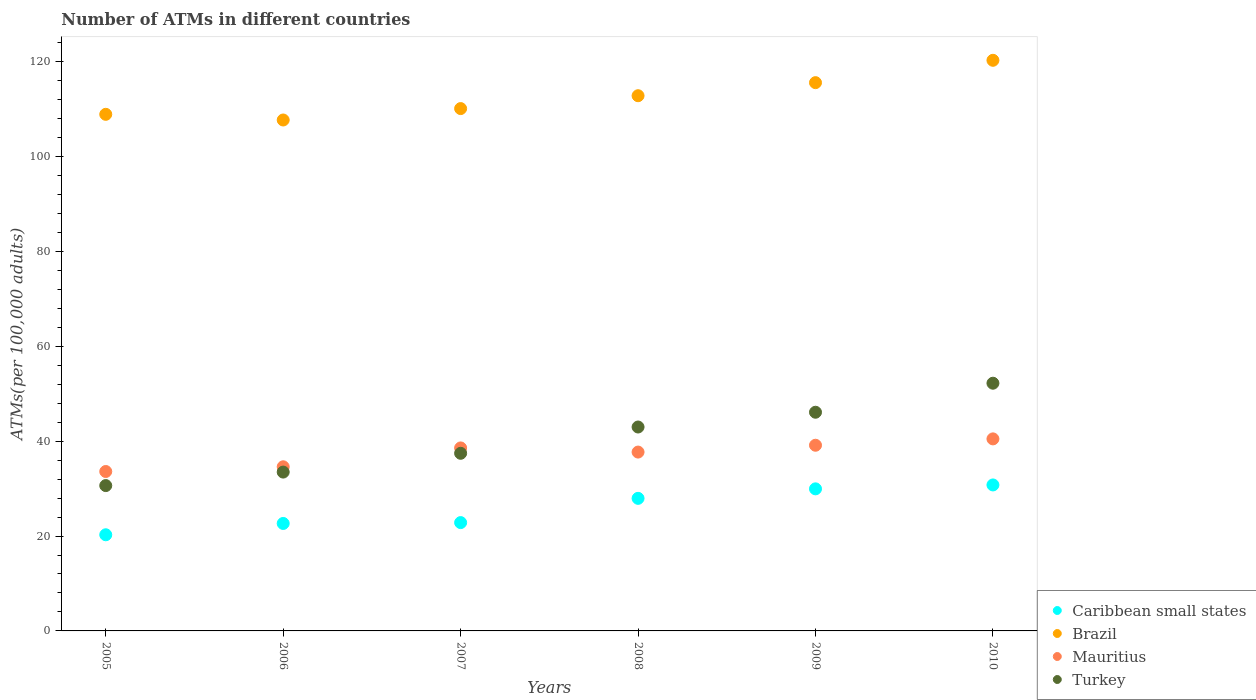What is the number of ATMs in Brazil in 2005?
Your answer should be compact. 108.88. Across all years, what is the maximum number of ATMs in Mauritius?
Your answer should be compact. 40.47. Across all years, what is the minimum number of ATMs in Turkey?
Your answer should be very brief. 30.63. In which year was the number of ATMs in Turkey maximum?
Offer a terse response. 2010. In which year was the number of ATMs in Mauritius minimum?
Provide a short and direct response. 2005. What is the total number of ATMs in Mauritius in the graph?
Provide a short and direct response. 224.06. What is the difference between the number of ATMs in Brazil in 2005 and that in 2010?
Provide a short and direct response. -11.39. What is the difference between the number of ATMs in Brazil in 2008 and the number of ATMs in Caribbean small states in 2007?
Offer a terse response. 89.97. What is the average number of ATMs in Turkey per year?
Provide a succinct answer. 40.47. In the year 2007, what is the difference between the number of ATMs in Caribbean small states and number of ATMs in Brazil?
Your answer should be very brief. -87.26. What is the ratio of the number of ATMs in Turkey in 2006 to that in 2010?
Offer a very short reply. 0.64. Is the number of ATMs in Turkey in 2006 less than that in 2007?
Provide a short and direct response. Yes. Is the difference between the number of ATMs in Caribbean small states in 2006 and 2009 greater than the difference between the number of ATMs in Brazil in 2006 and 2009?
Provide a succinct answer. Yes. What is the difference between the highest and the second highest number of ATMs in Mauritius?
Provide a succinct answer. 1.34. What is the difference between the highest and the lowest number of ATMs in Caribbean small states?
Offer a very short reply. 10.5. In how many years, is the number of ATMs in Turkey greater than the average number of ATMs in Turkey taken over all years?
Your response must be concise. 3. Is the sum of the number of ATMs in Turkey in 2008 and 2010 greater than the maximum number of ATMs in Mauritius across all years?
Keep it short and to the point. Yes. Does the number of ATMs in Turkey monotonically increase over the years?
Provide a succinct answer. Yes. Is the number of ATMs in Brazil strictly greater than the number of ATMs in Mauritius over the years?
Your response must be concise. Yes. Is the number of ATMs in Mauritius strictly less than the number of ATMs in Turkey over the years?
Provide a succinct answer. No. How many years are there in the graph?
Your answer should be very brief. 6. What is the difference between two consecutive major ticks on the Y-axis?
Offer a terse response. 20. Does the graph contain any zero values?
Offer a terse response. No. Does the graph contain grids?
Give a very brief answer. No. What is the title of the graph?
Give a very brief answer. Number of ATMs in different countries. What is the label or title of the X-axis?
Ensure brevity in your answer.  Years. What is the label or title of the Y-axis?
Provide a short and direct response. ATMs(per 100,0 adults). What is the ATMs(per 100,000 adults) of Caribbean small states in 2005?
Provide a short and direct response. 20.26. What is the ATMs(per 100,000 adults) of Brazil in 2005?
Keep it short and to the point. 108.88. What is the ATMs(per 100,000 adults) of Mauritius in 2005?
Offer a very short reply. 33.6. What is the ATMs(per 100,000 adults) in Turkey in 2005?
Your response must be concise. 30.63. What is the ATMs(per 100,000 adults) in Caribbean small states in 2006?
Your response must be concise. 22.65. What is the ATMs(per 100,000 adults) of Brazil in 2006?
Keep it short and to the point. 107.68. What is the ATMs(per 100,000 adults) of Mauritius in 2006?
Your response must be concise. 34.59. What is the ATMs(per 100,000 adults) of Turkey in 2006?
Offer a very short reply. 33.48. What is the ATMs(per 100,000 adults) of Caribbean small states in 2007?
Offer a terse response. 22.83. What is the ATMs(per 100,000 adults) of Brazil in 2007?
Provide a short and direct response. 110.09. What is the ATMs(per 100,000 adults) of Mauritius in 2007?
Give a very brief answer. 38.57. What is the ATMs(per 100,000 adults) of Turkey in 2007?
Your answer should be very brief. 37.44. What is the ATMs(per 100,000 adults) of Caribbean small states in 2008?
Your response must be concise. 27.94. What is the ATMs(per 100,000 adults) in Brazil in 2008?
Provide a short and direct response. 112.8. What is the ATMs(per 100,000 adults) of Mauritius in 2008?
Your response must be concise. 37.69. What is the ATMs(per 100,000 adults) in Turkey in 2008?
Offer a terse response. 42.98. What is the ATMs(per 100,000 adults) of Caribbean small states in 2009?
Provide a succinct answer. 29.94. What is the ATMs(per 100,000 adults) in Brazil in 2009?
Offer a terse response. 115.55. What is the ATMs(per 100,000 adults) in Mauritius in 2009?
Ensure brevity in your answer.  39.13. What is the ATMs(per 100,000 adults) of Turkey in 2009?
Keep it short and to the point. 46.09. What is the ATMs(per 100,000 adults) of Caribbean small states in 2010?
Offer a very short reply. 30.77. What is the ATMs(per 100,000 adults) of Brazil in 2010?
Your response must be concise. 120.26. What is the ATMs(per 100,000 adults) in Mauritius in 2010?
Your response must be concise. 40.47. What is the ATMs(per 100,000 adults) of Turkey in 2010?
Your answer should be compact. 52.21. Across all years, what is the maximum ATMs(per 100,000 adults) of Caribbean small states?
Give a very brief answer. 30.77. Across all years, what is the maximum ATMs(per 100,000 adults) of Brazil?
Provide a succinct answer. 120.26. Across all years, what is the maximum ATMs(per 100,000 adults) of Mauritius?
Offer a very short reply. 40.47. Across all years, what is the maximum ATMs(per 100,000 adults) of Turkey?
Your response must be concise. 52.21. Across all years, what is the minimum ATMs(per 100,000 adults) of Caribbean small states?
Make the answer very short. 20.26. Across all years, what is the minimum ATMs(per 100,000 adults) of Brazil?
Your answer should be compact. 107.68. Across all years, what is the minimum ATMs(per 100,000 adults) of Mauritius?
Your response must be concise. 33.6. Across all years, what is the minimum ATMs(per 100,000 adults) in Turkey?
Your answer should be very brief. 30.63. What is the total ATMs(per 100,000 adults) of Caribbean small states in the graph?
Ensure brevity in your answer.  154.39. What is the total ATMs(per 100,000 adults) of Brazil in the graph?
Provide a succinct answer. 675.26. What is the total ATMs(per 100,000 adults) of Mauritius in the graph?
Keep it short and to the point. 224.06. What is the total ATMs(per 100,000 adults) of Turkey in the graph?
Make the answer very short. 242.81. What is the difference between the ATMs(per 100,000 adults) in Caribbean small states in 2005 and that in 2006?
Provide a succinct answer. -2.38. What is the difference between the ATMs(per 100,000 adults) of Brazil in 2005 and that in 2006?
Your answer should be compact. 1.2. What is the difference between the ATMs(per 100,000 adults) in Mauritius in 2005 and that in 2006?
Offer a very short reply. -0.99. What is the difference between the ATMs(per 100,000 adults) in Turkey in 2005 and that in 2006?
Your answer should be compact. -2.85. What is the difference between the ATMs(per 100,000 adults) in Caribbean small states in 2005 and that in 2007?
Provide a succinct answer. -2.56. What is the difference between the ATMs(per 100,000 adults) of Brazil in 2005 and that in 2007?
Offer a terse response. -1.21. What is the difference between the ATMs(per 100,000 adults) in Mauritius in 2005 and that in 2007?
Your response must be concise. -4.97. What is the difference between the ATMs(per 100,000 adults) in Turkey in 2005 and that in 2007?
Provide a succinct answer. -6.81. What is the difference between the ATMs(per 100,000 adults) in Caribbean small states in 2005 and that in 2008?
Ensure brevity in your answer.  -7.68. What is the difference between the ATMs(per 100,000 adults) of Brazil in 2005 and that in 2008?
Make the answer very short. -3.92. What is the difference between the ATMs(per 100,000 adults) of Mauritius in 2005 and that in 2008?
Make the answer very short. -4.1. What is the difference between the ATMs(per 100,000 adults) of Turkey in 2005 and that in 2008?
Offer a terse response. -12.35. What is the difference between the ATMs(per 100,000 adults) in Caribbean small states in 2005 and that in 2009?
Make the answer very short. -9.68. What is the difference between the ATMs(per 100,000 adults) of Brazil in 2005 and that in 2009?
Give a very brief answer. -6.67. What is the difference between the ATMs(per 100,000 adults) in Mauritius in 2005 and that in 2009?
Keep it short and to the point. -5.53. What is the difference between the ATMs(per 100,000 adults) of Turkey in 2005 and that in 2009?
Offer a terse response. -15.46. What is the difference between the ATMs(per 100,000 adults) in Caribbean small states in 2005 and that in 2010?
Your answer should be very brief. -10.5. What is the difference between the ATMs(per 100,000 adults) of Brazil in 2005 and that in 2010?
Your answer should be very brief. -11.39. What is the difference between the ATMs(per 100,000 adults) of Mauritius in 2005 and that in 2010?
Provide a succinct answer. -6.88. What is the difference between the ATMs(per 100,000 adults) in Turkey in 2005 and that in 2010?
Ensure brevity in your answer.  -21.58. What is the difference between the ATMs(per 100,000 adults) in Caribbean small states in 2006 and that in 2007?
Provide a short and direct response. -0.18. What is the difference between the ATMs(per 100,000 adults) of Brazil in 2006 and that in 2007?
Your response must be concise. -2.4. What is the difference between the ATMs(per 100,000 adults) in Mauritius in 2006 and that in 2007?
Your answer should be compact. -3.97. What is the difference between the ATMs(per 100,000 adults) in Turkey in 2006 and that in 2007?
Make the answer very short. -3.96. What is the difference between the ATMs(per 100,000 adults) in Caribbean small states in 2006 and that in 2008?
Your answer should be compact. -5.29. What is the difference between the ATMs(per 100,000 adults) of Brazil in 2006 and that in 2008?
Give a very brief answer. -5.12. What is the difference between the ATMs(per 100,000 adults) of Mauritius in 2006 and that in 2008?
Ensure brevity in your answer.  -3.1. What is the difference between the ATMs(per 100,000 adults) in Turkey in 2006 and that in 2008?
Your response must be concise. -9.5. What is the difference between the ATMs(per 100,000 adults) of Caribbean small states in 2006 and that in 2009?
Offer a very short reply. -7.29. What is the difference between the ATMs(per 100,000 adults) in Brazil in 2006 and that in 2009?
Give a very brief answer. -7.87. What is the difference between the ATMs(per 100,000 adults) of Mauritius in 2006 and that in 2009?
Give a very brief answer. -4.54. What is the difference between the ATMs(per 100,000 adults) in Turkey in 2006 and that in 2009?
Offer a terse response. -12.61. What is the difference between the ATMs(per 100,000 adults) of Caribbean small states in 2006 and that in 2010?
Offer a terse response. -8.12. What is the difference between the ATMs(per 100,000 adults) in Brazil in 2006 and that in 2010?
Your response must be concise. -12.58. What is the difference between the ATMs(per 100,000 adults) of Mauritius in 2006 and that in 2010?
Keep it short and to the point. -5.88. What is the difference between the ATMs(per 100,000 adults) in Turkey in 2006 and that in 2010?
Keep it short and to the point. -18.73. What is the difference between the ATMs(per 100,000 adults) of Caribbean small states in 2007 and that in 2008?
Ensure brevity in your answer.  -5.11. What is the difference between the ATMs(per 100,000 adults) of Brazil in 2007 and that in 2008?
Give a very brief answer. -2.71. What is the difference between the ATMs(per 100,000 adults) of Mauritius in 2007 and that in 2008?
Your response must be concise. 0.87. What is the difference between the ATMs(per 100,000 adults) in Turkey in 2007 and that in 2008?
Offer a terse response. -5.54. What is the difference between the ATMs(per 100,000 adults) of Caribbean small states in 2007 and that in 2009?
Offer a terse response. -7.11. What is the difference between the ATMs(per 100,000 adults) in Brazil in 2007 and that in 2009?
Offer a very short reply. -5.47. What is the difference between the ATMs(per 100,000 adults) in Mauritius in 2007 and that in 2009?
Offer a very short reply. -0.56. What is the difference between the ATMs(per 100,000 adults) of Turkey in 2007 and that in 2009?
Your response must be concise. -8.65. What is the difference between the ATMs(per 100,000 adults) of Caribbean small states in 2007 and that in 2010?
Provide a succinct answer. -7.94. What is the difference between the ATMs(per 100,000 adults) in Brazil in 2007 and that in 2010?
Give a very brief answer. -10.18. What is the difference between the ATMs(per 100,000 adults) of Mauritius in 2007 and that in 2010?
Offer a terse response. -1.91. What is the difference between the ATMs(per 100,000 adults) of Turkey in 2007 and that in 2010?
Your response must be concise. -14.77. What is the difference between the ATMs(per 100,000 adults) of Caribbean small states in 2008 and that in 2009?
Offer a terse response. -2. What is the difference between the ATMs(per 100,000 adults) of Brazil in 2008 and that in 2009?
Your answer should be compact. -2.75. What is the difference between the ATMs(per 100,000 adults) in Mauritius in 2008 and that in 2009?
Give a very brief answer. -1.44. What is the difference between the ATMs(per 100,000 adults) of Turkey in 2008 and that in 2009?
Provide a succinct answer. -3.11. What is the difference between the ATMs(per 100,000 adults) in Caribbean small states in 2008 and that in 2010?
Make the answer very short. -2.83. What is the difference between the ATMs(per 100,000 adults) in Brazil in 2008 and that in 2010?
Offer a very short reply. -7.46. What is the difference between the ATMs(per 100,000 adults) of Mauritius in 2008 and that in 2010?
Provide a short and direct response. -2.78. What is the difference between the ATMs(per 100,000 adults) of Turkey in 2008 and that in 2010?
Ensure brevity in your answer.  -9.23. What is the difference between the ATMs(per 100,000 adults) of Caribbean small states in 2009 and that in 2010?
Keep it short and to the point. -0.82. What is the difference between the ATMs(per 100,000 adults) of Brazil in 2009 and that in 2010?
Provide a succinct answer. -4.71. What is the difference between the ATMs(per 100,000 adults) of Mauritius in 2009 and that in 2010?
Give a very brief answer. -1.34. What is the difference between the ATMs(per 100,000 adults) in Turkey in 2009 and that in 2010?
Your response must be concise. -6.12. What is the difference between the ATMs(per 100,000 adults) of Caribbean small states in 2005 and the ATMs(per 100,000 adults) of Brazil in 2006?
Provide a short and direct response. -87.42. What is the difference between the ATMs(per 100,000 adults) of Caribbean small states in 2005 and the ATMs(per 100,000 adults) of Mauritius in 2006?
Your answer should be very brief. -14.33. What is the difference between the ATMs(per 100,000 adults) of Caribbean small states in 2005 and the ATMs(per 100,000 adults) of Turkey in 2006?
Give a very brief answer. -13.21. What is the difference between the ATMs(per 100,000 adults) of Brazil in 2005 and the ATMs(per 100,000 adults) of Mauritius in 2006?
Ensure brevity in your answer.  74.28. What is the difference between the ATMs(per 100,000 adults) of Brazil in 2005 and the ATMs(per 100,000 adults) of Turkey in 2006?
Your answer should be compact. 75.4. What is the difference between the ATMs(per 100,000 adults) of Mauritius in 2005 and the ATMs(per 100,000 adults) of Turkey in 2006?
Provide a succinct answer. 0.12. What is the difference between the ATMs(per 100,000 adults) in Caribbean small states in 2005 and the ATMs(per 100,000 adults) in Brazil in 2007?
Provide a short and direct response. -89.82. What is the difference between the ATMs(per 100,000 adults) in Caribbean small states in 2005 and the ATMs(per 100,000 adults) in Mauritius in 2007?
Offer a very short reply. -18.3. What is the difference between the ATMs(per 100,000 adults) of Caribbean small states in 2005 and the ATMs(per 100,000 adults) of Turkey in 2007?
Offer a terse response. -17.17. What is the difference between the ATMs(per 100,000 adults) of Brazil in 2005 and the ATMs(per 100,000 adults) of Mauritius in 2007?
Make the answer very short. 70.31. What is the difference between the ATMs(per 100,000 adults) of Brazil in 2005 and the ATMs(per 100,000 adults) of Turkey in 2007?
Offer a terse response. 71.44. What is the difference between the ATMs(per 100,000 adults) of Mauritius in 2005 and the ATMs(per 100,000 adults) of Turkey in 2007?
Ensure brevity in your answer.  -3.84. What is the difference between the ATMs(per 100,000 adults) in Caribbean small states in 2005 and the ATMs(per 100,000 adults) in Brazil in 2008?
Offer a very short reply. -92.53. What is the difference between the ATMs(per 100,000 adults) in Caribbean small states in 2005 and the ATMs(per 100,000 adults) in Mauritius in 2008?
Your answer should be very brief. -17.43. What is the difference between the ATMs(per 100,000 adults) of Caribbean small states in 2005 and the ATMs(per 100,000 adults) of Turkey in 2008?
Keep it short and to the point. -22.71. What is the difference between the ATMs(per 100,000 adults) in Brazil in 2005 and the ATMs(per 100,000 adults) in Mauritius in 2008?
Offer a very short reply. 71.18. What is the difference between the ATMs(per 100,000 adults) in Brazil in 2005 and the ATMs(per 100,000 adults) in Turkey in 2008?
Offer a very short reply. 65.9. What is the difference between the ATMs(per 100,000 adults) of Mauritius in 2005 and the ATMs(per 100,000 adults) of Turkey in 2008?
Provide a succinct answer. -9.38. What is the difference between the ATMs(per 100,000 adults) of Caribbean small states in 2005 and the ATMs(per 100,000 adults) of Brazil in 2009?
Provide a succinct answer. -95.29. What is the difference between the ATMs(per 100,000 adults) of Caribbean small states in 2005 and the ATMs(per 100,000 adults) of Mauritius in 2009?
Your response must be concise. -18.87. What is the difference between the ATMs(per 100,000 adults) of Caribbean small states in 2005 and the ATMs(per 100,000 adults) of Turkey in 2009?
Keep it short and to the point. -25.82. What is the difference between the ATMs(per 100,000 adults) in Brazil in 2005 and the ATMs(per 100,000 adults) in Mauritius in 2009?
Your answer should be very brief. 69.74. What is the difference between the ATMs(per 100,000 adults) in Brazil in 2005 and the ATMs(per 100,000 adults) in Turkey in 2009?
Your answer should be very brief. 62.79. What is the difference between the ATMs(per 100,000 adults) of Mauritius in 2005 and the ATMs(per 100,000 adults) of Turkey in 2009?
Offer a terse response. -12.49. What is the difference between the ATMs(per 100,000 adults) in Caribbean small states in 2005 and the ATMs(per 100,000 adults) in Brazil in 2010?
Offer a terse response. -100. What is the difference between the ATMs(per 100,000 adults) in Caribbean small states in 2005 and the ATMs(per 100,000 adults) in Mauritius in 2010?
Your answer should be compact. -20.21. What is the difference between the ATMs(per 100,000 adults) of Caribbean small states in 2005 and the ATMs(per 100,000 adults) of Turkey in 2010?
Your response must be concise. -31.94. What is the difference between the ATMs(per 100,000 adults) in Brazil in 2005 and the ATMs(per 100,000 adults) in Mauritius in 2010?
Offer a very short reply. 68.4. What is the difference between the ATMs(per 100,000 adults) in Brazil in 2005 and the ATMs(per 100,000 adults) in Turkey in 2010?
Offer a very short reply. 56.67. What is the difference between the ATMs(per 100,000 adults) of Mauritius in 2005 and the ATMs(per 100,000 adults) of Turkey in 2010?
Your answer should be compact. -18.61. What is the difference between the ATMs(per 100,000 adults) of Caribbean small states in 2006 and the ATMs(per 100,000 adults) of Brazil in 2007?
Make the answer very short. -87.44. What is the difference between the ATMs(per 100,000 adults) in Caribbean small states in 2006 and the ATMs(per 100,000 adults) in Mauritius in 2007?
Provide a succinct answer. -15.92. What is the difference between the ATMs(per 100,000 adults) in Caribbean small states in 2006 and the ATMs(per 100,000 adults) in Turkey in 2007?
Your answer should be compact. -14.79. What is the difference between the ATMs(per 100,000 adults) in Brazil in 2006 and the ATMs(per 100,000 adults) in Mauritius in 2007?
Provide a short and direct response. 69.11. What is the difference between the ATMs(per 100,000 adults) of Brazil in 2006 and the ATMs(per 100,000 adults) of Turkey in 2007?
Your answer should be very brief. 70.25. What is the difference between the ATMs(per 100,000 adults) of Mauritius in 2006 and the ATMs(per 100,000 adults) of Turkey in 2007?
Provide a succinct answer. -2.84. What is the difference between the ATMs(per 100,000 adults) of Caribbean small states in 2006 and the ATMs(per 100,000 adults) of Brazil in 2008?
Keep it short and to the point. -90.15. What is the difference between the ATMs(per 100,000 adults) of Caribbean small states in 2006 and the ATMs(per 100,000 adults) of Mauritius in 2008?
Your response must be concise. -15.04. What is the difference between the ATMs(per 100,000 adults) in Caribbean small states in 2006 and the ATMs(per 100,000 adults) in Turkey in 2008?
Provide a succinct answer. -20.33. What is the difference between the ATMs(per 100,000 adults) in Brazil in 2006 and the ATMs(per 100,000 adults) in Mauritius in 2008?
Offer a terse response. 69.99. What is the difference between the ATMs(per 100,000 adults) of Brazil in 2006 and the ATMs(per 100,000 adults) of Turkey in 2008?
Your answer should be very brief. 64.71. What is the difference between the ATMs(per 100,000 adults) of Mauritius in 2006 and the ATMs(per 100,000 adults) of Turkey in 2008?
Provide a succinct answer. -8.38. What is the difference between the ATMs(per 100,000 adults) in Caribbean small states in 2006 and the ATMs(per 100,000 adults) in Brazil in 2009?
Your answer should be very brief. -92.9. What is the difference between the ATMs(per 100,000 adults) of Caribbean small states in 2006 and the ATMs(per 100,000 adults) of Mauritius in 2009?
Offer a very short reply. -16.48. What is the difference between the ATMs(per 100,000 adults) in Caribbean small states in 2006 and the ATMs(per 100,000 adults) in Turkey in 2009?
Ensure brevity in your answer.  -23.44. What is the difference between the ATMs(per 100,000 adults) of Brazil in 2006 and the ATMs(per 100,000 adults) of Mauritius in 2009?
Your answer should be compact. 68.55. What is the difference between the ATMs(per 100,000 adults) of Brazil in 2006 and the ATMs(per 100,000 adults) of Turkey in 2009?
Your response must be concise. 61.59. What is the difference between the ATMs(per 100,000 adults) of Mauritius in 2006 and the ATMs(per 100,000 adults) of Turkey in 2009?
Ensure brevity in your answer.  -11.5. What is the difference between the ATMs(per 100,000 adults) of Caribbean small states in 2006 and the ATMs(per 100,000 adults) of Brazil in 2010?
Keep it short and to the point. -97.61. What is the difference between the ATMs(per 100,000 adults) of Caribbean small states in 2006 and the ATMs(per 100,000 adults) of Mauritius in 2010?
Offer a very short reply. -17.82. What is the difference between the ATMs(per 100,000 adults) in Caribbean small states in 2006 and the ATMs(per 100,000 adults) in Turkey in 2010?
Give a very brief answer. -29.56. What is the difference between the ATMs(per 100,000 adults) in Brazil in 2006 and the ATMs(per 100,000 adults) in Mauritius in 2010?
Offer a very short reply. 67.21. What is the difference between the ATMs(per 100,000 adults) in Brazil in 2006 and the ATMs(per 100,000 adults) in Turkey in 2010?
Offer a very short reply. 55.48. What is the difference between the ATMs(per 100,000 adults) of Mauritius in 2006 and the ATMs(per 100,000 adults) of Turkey in 2010?
Offer a very short reply. -17.61. What is the difference between the ATMs(per 100,000 adults) of Caribbean small states in 2007 and the ATMs(per 100,000 adults) of Brazil in 2008?
Your answer should be compact. -89.97. What is the difference between the ATMs(per 100,000 adults) in Caribbean small states in 2007 and the ATMs(per 100,000 adults) in Mauritius in 2008?
Provide a short and direct response. -14.86. What is the difference between the ATMs(per 100,000 adults) in Caribbean small states in 2007 and the ATMs(per 100,000 adults) in Turkey in 2008?
Your answer should be very brief. -20.15. What is the difference between the ATMs(per 100,000 adults) in Brazil in 2007 and the ATMs(per 100,000 adults) in Mauritius in 2008?
Give a very brief answer. 72.39. What is the difference between the ATMs(per 100,000 adults) in Brazil in 2007 and the ATMs(per 100,000 adults) in Turkey in 2008?
Your response must be concise. 67.11. What is the difference between the ATMs(per 100,000 adults) in Mauritius in 2007 and the ATMs(per 100,000 adults) in Turkey in 2008?
Offer a very short reply. -4.41. What is the difference between the ATMs(per 100,000 adults) of Caribbean small states in 2007 and the ATMs(per 100,000 adults) of Brazil in 2009?
Provide a succinct answer. -92.72. What is the difference between the ATMs(per 100,000 adults) of Caribbean small states in 2007 and the ATMs(per 100,000 adults) of Mauritius in 2009?
Provide a short and direct response. -16.3. What is the difference between the ATMs(per 100,000 adults) of Caribbean small states in 2007 and the ATMs(per 100,000 adults) of Turkey in 2009?
Provide a succinct answer. -23.26. What is the difference between the ATMs(per 100,000 adults) of Brazil in 2007 and the ATMs(per 100,000 adults) of Mauritius in 2009?
Offer a very short reply. 70.95. What is the difference between the ATMs(per 100,000 adults) in Brazil in 2007 and the ATMs(per 100,000 adults) in Turkey in 2009?
Your response must be concise. 64. What is the difference between the ATMs(per 100,000 adults) of Mauritius in 2007 and the ATMs(per 100,000 adults) of Turkey in 2009?
Offer a terse response. -7.52. What is the difference between the ATMs(per 100,000 adults) of Caribbean small states in 2007 and the ATMs(per 100,000 adults) of Brazil in 2010?
Keep it short and to the point. -97.43. What is the difference between the ATMs(per 100,000 adults) of Caribbean small states in 2007 and the ATMs(per 100,000 adults) of Mauritius in 2010?
Offer a terse response. -17.64. What is the difference between the ATMs(per 100,000 adults) of Caribbean small states in 2007 and the ATMs(per 100,000 adults) of Turkey in 2010?
Give a very brief answer. -29.38. What is the difference between the ATMs(per 100,000 adults) in Brazil in 2007 and the ATMs(per 100,000 adults) in Mauritius in 2010?
Offer a terse response. 69.61. What is the difference between the ATMs(per 100,000 adults) in Brazil in 2007 and the ATMs(per 100,000 adults) in Turkey in 2010?
Make the answer very short. 57.88. What is the difference between the ATMs(per 100,000 adults) of Mauritius in 2007 and the ATMs(per 100,000 adults) of Turkey in 2010?
Ensure brevity in your answer.  -13.64. What is the difference between the ATMs(per 100,000 adults) in Caribbean small states in 2008 and the ATMs(per 100,000 adults) in Brazil in 2009?
Your response must be concise. -87.61. What is the difference between the ATMs(per 100,000 adults) of Caribbean small states in 2008 and the ATMs(per 100,000 adults) of Mauritius in 2009?
Offer a very short reply. -11.19. What is the difference between the ATMs(per 100,000 adults) of Caribbean small states in 2008 and the ATMs(per 100,000 adults) of Turkey in 2009?
Offer a very short reply. -18.15. What is the difference between the ATMs(per 100,000 adults) of Brazil in 2008 and the ATMs(per 100,000 adults) of Mauritius in 2009?
Your answer should be compact. 73.67. What is the difference between the ATMs(per 100,000 adults) in Brazil in 2008 and the ATMs(per 100,000 adults) in Turkey in 2009?
Give a very brief answer. 66.71. What is the difference between the ATMs(per 100,000 adults) in Mauritius in 2008 and the ATMs(per 100,000 adults) in Turkey in 2009?
Make the answer very short. -8.4. What is the difference between the ATMs(per 100,000 adults) of Caribbean small states in 2008 and the ATMs(per 100,000 adults) of Brazil in 2010?
Your answer should be very brief. -92.32. What is the difference between the ATMs(per 100,000 adults) of Caribbean small states in 2008 and the ATMs(per 100,000 adults) of Mauritius in 2010?
Offer a terse response. -12.53. What is the difference between the ATMs(per 100,000 adults) in Caribbean small states in 2008 and the ATMs(per 100,000 adults) in Turkey in 2010?
Your response must be concise. -24.27. What is the difference between the ATMs(per 100,000 adults) of Brazil in 2008 and the ATMs(per 100,000 adults) of Mauritius in 2010?
Ensure brevity in your answer.  72.33. What is the difference between the ATMs(per 100,000 adults) in Brazil in 2008 and the ATMs(per 100,000 adults) in Turkey in 2010?
Ensure brevity in your answer.  60.59. What is the difference between the ATMs(per 100,000 adults) in Mauritius in 2008 and the ATMs(per 100,000 adults) in Turkey in 2010?
Your answer should be very brief. -14.51. What is the difference between the ATMs(per 100,000 adults) of Caribbean small states in 2009 and the ATMs(per 100,000 adults) of Brazil in 2010?
Provide a succinct answer. -90.32. What is the difference between the ATMs(per 100,000 adults) in Caribbean small states in 2009 and the ATMs(per 100,000 adults) in Mauritius in 2010?
Your answer should be compact. -10.53. What is the difference between the ATMs(per 100,000 adults) of Caribbean small states in 2009 and the ATMs(per 100,000 adults) of Turkey in 2010?
Provide a succinct answer. -22.26. What is the difference between the ATMs(per 100,000 adults) in Brazil in 2009 and the ATMs(per 100,000 adults) in Mauritius in 2010?
Offer a very short reply. 75.08. What is the difference between the ATMs(per 100,000 adults) of Brazil in 2009 and the ATMs(per 100,000 adults) of Turkey in 2010?
Your response must be concise. 63.35. What is the difference between the ATMs(per 100,000 adults) in Mauritius in 2009 and the ATMs(per 100,000 adults) in Turkey in 2010?
Your answer should be very brief. -13.07. What is the average ATMs(per 100,000 adults) of Caribbean small states per year?
Keep it short and to the point. 25.73. What is the average ATMs(per 100,000 adults) in Brazil per year?
Give a very brief answer. 112.54. What is the average ATMs(per 100,000 adults) in Mauritius per year?
Your answer should be very brief. 37.34. What is the average ATMs(per 100,000 adults) in Turkey per year?
Ensure brevity in your answer.  40.47. In the year 2005, what is the difference between the ATMs(per 100,000 adults) in Caribbean small states and ATMs(per 100,000 adults) in Brazil?
Your response must be concise. -88.61. In the year 2005, what is the difference between the ATMs(per 100,000 adults) of Caribbean small states and ATMs(per 100,000 adults) of Mauritius?
Keep it short and to the point. -13.33. In the year 2005, what is the difference between the ATMs(per 100,000 adults) in Caribbean small states and ATMs(per 100,000 adults) in Turkey?
Your response must be concise. -10.37. In the year 2005, what is the difference between the ATMs(per 100,000 adults) in Brazil and ATMs(per 100,000 adults) in Mauritius?
Give a very brief answer. 75.28. In the year 2005, what is the difference between the ATMs(per 100,000 adults) in Brazil and ATMs(per 100,000 adults) in Turkey?
Make the answer very short. 78.25. In the year 2005, what is the difference between the ATMs(per 100,000 adults) in Mauritius and ATMs(per 100,000 adults) in Turkey?
Keep it short and to the point. 2.97. In the year 2006, what is the difference between the ATMs(per 100,000 adults) of Caribbean small states and ATMs(per 100,000 adults) of Brazil?
Keep it short and to the point. -85.03. In the year 2006, what is the difference between the ATMs(per 100,000 adults) of Caribbean small states and ATMs(per 100,000 adults) of Mauritius?
Your answer should be compact. -11.94. In the year 2006, what is the difference between the ATMs(per 100,000 adults) in Caribbean small states and ATMs(per 100,000 adults) in Turkey?
Your answer should be very brief. -10.83. In the year 2006, what is the difference between the ATMs(per 100,000 adults) in Brazil and ATMs(per 100,000 adults) in Mauritius?
Your answer should be very brief. 73.09. In the year 2006, what is the difference between the ATMs(per 100,000 adults) in Brazil and ATMs(per 100,000 adults) in Turkey?
Provide a succinct answer. 74.21. In the year 2006, what is the difference between the ATMs(per 100,000 adults) in Mauritius and ATMs(per 100,000 adults) in Turkey?
Offer a terse response. 1.12. In the year 2007, what is the difference between the ATMs(per 100,000 adults) in Caribbean small states and ATMs(per 100,000 adults) in Brazil?
Your response must be concise. -87.26. In the year 2007, what is the difference between the ATMs(per 100,000 adults) of Caribbean small states and ATMs(per 100,000 adults) of Mauritius?
Ensure brevity in your answer.  -15.74. In the year 2007, what is the difference between the ATMs(per 100,000 adults) of Caribbean small states and ATMs(per 100,000 adults) of Turkey?
Offer a terse response. -14.61. In the year 2007, what is the difference between the ATMs(per 100,000 adults) in Brazil and ATMs(per 100,000 adults) in Mauritius?
Keep it short and to the point. 71.52. In the year 2007, what is the difference between the ATMs(per 100,000 adults) in Brazil and ATMs(per 100,000 adults) in Turkey?
Make the answer very short. 72.65. In the year 2007, what is the difference between the ATMs(per 100,000 adults) of Mauritius and ATMs(per 100,000 adults) of Turkey?
Make the answer very short. 1.13. In the year 2008, what is the difference between the ATMs(per 100,000 adults) in Caribbean small states and ATMs(per 100,000 adults) in Brazil?
Your answer should be compact. -84.86. In the year 2008, what is the difference between the ATMs(per 100,000 adults) in Caribbean small states and ATMs(per 100,000 adults) in Mauritius?
Make the answer very short. -9.75. In the year 2008, what is the difference between the ATMs(per 100,000 adults) in Caribbean small states and ATMs(per 100,000 adults) in Turkey?
Provide a short and direct response. -15.04. In the year 2008, what is the difference between the ATMs(per 100,000 adults) in Brazil and ATMs(per 100,000 adults) in Mauritius?
Your answer should be very brief. 75.1. In the year 2008, what is the difference between the ATMs(per 100,000 adults) of Brazil and ATMs(per 100,000 adults) of Turkey?
Offer a very short reply. 69.82. In the year 2008, what is the difference between the ATMs(per 100,000 adults) in Mauritius and ATMs(per 100,000 adults) in Turkey?
Provide a short and direct response. -5.28. In the year 2009, what is the difference between the ATMs(per 100,000 adults) in Caribbean small states and ATMs(per 100,000 adults) in Brazil?
Provide a short and direct response. -85.61. In the year 2009, what is the difference between the ATMs(per 100,000 adults) of Caribbean small states and ATMs(per 100,000 adults) of Mauritius?
Provide a short and direct response. -9.19. In the year 2009, what is the difference between the ATMs(per 100,000 adults) in Caribbean small states and ATMs(per 100,000 adults) in Turkey?
Provide a short and direct response. -16.15. In the year 2009, what is the difference between the ATMs(per 100,000 adults) in Brazil and ATMs(per 100,000 adults) in Mauritius?
Your response must be concise. 76.42. In the year 2009, what is the difference between the ATMs(per 100,000 adults) in Brazil and ATMs(per 100,000 adults) in Turkey?
Give a very brief answer. 69.46. In the year 2009, what is the difference between the ATMs(per 100,000 adults) of Mauritius and ATMs(per 100,000 adults) of Turkey?
Offer a terse response. -6.96. In the year 2010, what is the difference between the ATMs(per 100,000 adults) in Caribbean small states and ATMs(per 100,000 adults) in Brazil?
Provide a short and direct response. -89.5. In the year 2010, what is the difference between the ATMs(per 100,000 adults) of Caribbean small states and ATMs(per 100,000 adults) of Mauritius?
Provide a short and direct response. -9.71. In the year 2010, what is the difference between the ATMs(per 100,000 adults) of Caribbean small states and ATMs(per 100,000 adults) of Turkey?
Provide a short and direct response. -21.44. In the year 2010, what is the difference between the ATMs(per 100,000 adults) of Brazil and ATMs(per 100,000 adults) of Mauritius?
Make the answer very short. 79.79. In the year 2010, what is the difference between the ATMs(per 100,000 adults) in Brazil and ATMs(per 100,000 adults) in Turkey?
Provide a succinct answer. 68.06. In the year 2010, what is the difference between the ATMs(per 100,000 adults) in Mauritius and ATMs(per 100,000 adults) in Turkey?
Provide a succinct answer. -11.73. What is the ratio of the ATMs(per 100,000 adults) of Caribbean small states in 2005 to that in 2006?
Your answer should be compact. 0.89. What is the ratio of the ATMs(per 100,000 adults) in Brazil in 2005 to that in 2006?
Keep it short and to the point. 1.01. What is the ratio of the ATMs(per 100,000 adults) in Mauritius in 2005 to that in 2006?
Give a very brief answer. 0.97. What is the ratio of the ATMs(per 100,000 adults) of Turkey in 2005 to that in 2006?
Offer a terse response. 0.92. What is the ratio of the ATMs(per 100,000 adults) of Caribbean small states in 2005 to that in 2007?
Offer a terse response. 0.89. What is the ratio of the ATMs(per 100,000 adults) of Mauritius in 2005 to that in 2007?
Offer a very short reply. 0.87. What is the ratio of the ATMs(per 100,000 adults) in Turkey in 2005 to that in 2007?
Make the answer very short. 0.82. What is the ratio of the ATMs(per 100,000 adults) in Caribbean small states in 2005 to that in 2008?
Your answer should be very brief. 0.73. What is the ratio of the ATMs(per 100,000 adults) of Brazil in 2005 to that in 2008?
Offer a terse response. 0.97. What is the ratio of the ATMs(per 100,000 adults) of Mauritius in 2005 to that in 2008?
Give a very brief answer. 0.89. What is the ratio of the ATMs(per 100,000 adults) in Turkey in 2005 to that in 2008?
Your answer should be compact. 0.71. What is the ratio of the ATMs(per 100,000 adults) of Caribbean small states in 2005 to that in 2009?
Your response must be concise. 0.68. What is the ratio of the ATMs(per 100,000 adults) in Brazil in 2005 to that in 2009?
Make the answer very short. 0.94. What is the ratio of the ATMs(per 100,000 adults) in Mauritius in 2005 to that in 2009?
Ensure brevity in your answer.  0.86. What is the ratio of the ATMs(per 100,000 adults) in Turkey in 2005 to that in 2009?
Your answer should be very brief. 0.66. What is the ratio of the ATMs(per 100,000 adults) of Caribbean small states in 2005 to that in 2010?
Keep it short and to the point. 0.66. What is the ratio of the ATMs(per 100,000 adults) of Brazil in 2005 to that in 2010?
Ensure brevity in your answer.  0.91. What is the ratio of the ATMs(per 100,000 adults) in Mauritius in 2005 to that in 2010?
Give a very brief answer. 0.83. What is the ratio of the ATMs(per 100,000 adults) in Turkey in 2005 to that in 2010?
Make the answer very short. 0.59. What is the ratio of the ATMs(per 100,000 adults) in Brazil in 2006 to that in 2007?
Give a very brief answer. 0.98. What is the ratio of the ATMs(per 100,000 adults) in Mauritius in 2006 to that in 2007?
Keep it short and to the point. 0.9. What is the ratio of the ATMs(per 100,000 adults) of Turkey in 2006 to that in 2007?
Give a very brief answer. 0.89. What is the ratio of the ATMs(per 100,000 adults) of Caribbean small states in 2006 to that in 2008?
Give a very brief answer. 0.81. What is the ratio of the ATMs(per 100,000 adults) in Brazil in 2006 to that in 2008?
Your answer should be compact. 0.95. What is the ratio of the ATMs(per 100,000 adults) in Mauritius in 2006 to that in 2008?
Give a very brief answer. 0.92. What is the ratio of the ATMs(per 100,000 adults) in Turkey in 2006 to that in 2008?
Ensure brevity in your answer.  0.78. What is the ratio of the ATMs(per 100,000 adults) of Caribbean small states in 2006 to that in 2009?
Ensure brevity in your answer.  0.76. What is the ratio of the ATMs(per 100,000 adults) of Brazil in 2006 to that in 2009?
Your answer should be very brief. 0.93. What is the ratio of the ATMs(per 100,000 adults) of Mauritius in 2006 to that in 2009?
Offer a terse response. 0.88. What is the ratio of the ATMs(per 100,000 adults) of Turkey in 2006 to that in 2009?
Offer a terse response. 0.73. What is the ratio of the ATMs(per 100,000 adults) in Caribbean small states in 2006 to that in 2010?
Provide a short and direct response. 0.74. What is the ratio of the ATMs(per 100,000 adults) in Brazil in 2006 to that in 2010?
Offer a very short reply. 0.9. What is the ratio of the ATMs(per 100,000 adults) in Mauritius in 2006 to that in 2010?
Offer a very short reply. 0.85. What is the ratio of the ATMs(per 100,000 adults) in Turkey in 2006 to that in 2010?
Make the answer very short. 0.64. What is the ratio of the ATMs(per 100,000 adults) of Caribbean small states in 2007 to that in 2008?
Make the answer very short. 0.82. What is the ratio of the ATMs(per 100,000 adults) of Mauritius in 2007 to that in 2008?
Your answer should be compact. 1.02. What is the ratio of the ATMs(per 100,000 adults) in Turkey in 2007 to that in 2008?
Give a very brief answer. 0.87. What is the ratio of the ATMs(per 100,000 adults) in Caribbean small states in 2007 to that in 2009?
Keep it short and to the point. 0.76. What is the ratio of the ATMs(per 100,000 adults) in Brazil in 2007 to that in 2009?
Your answer should be compact. 0.95. What is the ratio of the ATMs(per 100,000 adults) in Mauritius in 2007 to that in 2009?
Ensure brevity in your answer.  0.99. What is the ratio of the ATMs(per 100,000 adults) in Turkey in 2007 to that in 2009?
Keep it short and to the point. 0.81. What is the ratio of the ATMs(per 100,000 adults) of Caribbean small states in 2007 to that in 2010?
Your response must be concise. 0.74. What is the ratio of the ATMs(per 100,000 adults) in Brazil in 2007 to that in 2010?
Offer a terse response. 0.92. What is the ratio of the ATMs(per 100,000 adults) in Mauritius in 2007 to that in 2010?
Provide a short and direct response. 0.95. What is the ratio of the ATMs(per 100,000 adults) of Turkey in 2007 to that in 2010?
Provide a succinct answer. 0.72. What is the ratio of the ATMs(per 100,000 adults) in Caribbean small states in 2008 to that in 2009?
Your response must be concise. 0.93. What is the ratio of the ATMs(per 100,000 adults) in Brazil in 2008 to that in 2009?
Offer a terse response. 0.98. What is the ratio of the ATMs(per 100,000 adults) in Mauritius in 2008 to that in 2009?
Offer a terse response. 0.96. What is the ratio of the ATMs(per 100,000 adults) in Turkey in 2008 to that in 2009?
Ensure brevity in your answer.  0.93. What is the ratio of the ATMs(per 100,000 adults) in Caribbean small states in 2008 to that in 2010?
Your answer should be very brief. 0.91. What is the ratio of the ATMs(per 100,000 adults) of Brazil in 2008 to that in 2010?
Make the answer very short. 0.94. What is the ratio of the ATMs(per 100,000 adults) in Mauritius in 2008 to that in 2010?
Your answer should be very brief. 0.93. What is the ratio of the ATMs(per 100,000 adults) of Turkey in 2008 to that in 2010?
Keep it short and to the point. 0.82. What is the ratio of the ATMs(per 100,000 adults) in Caribbean small states in 2009 to that in 2010?
Give a very brief answer. 0.97. What is the ratio of the ATMs(per 100,000 adults) of Brazil in 2009 to that in 2010?
Provide a succinct answer. 0.96. What is the ratio of the ATMs(per 100,000 adults) of Mauritius in 2009 to that in 2010?
Ensure brevity in your answer.  0.97. What is the ratio of the ATMs(per 100,000 adults) in Turkey in 2009 to that in 2010?
Your answer should be very brief. 0.88. What is the difference between the highest and the second highest ATMs(per 100,000 adults) of Caribbean small states?
Your answer should be very brief. 0.82. What is the difference between the highest and the second highest ATMs(per 100,000 adults) in Brazil?
Provide a succinct answer. 4.71. What is the difference between the highest and the second highest ATMs(per 100,000 adults) of Mauritius?
Give a very brief answer. 1.34. What is the difference between the highest and the second highest ATMs(per 100,000 adults) in Turkey?
Give a very brief answer. 6.12. What is the difference between the highest and the lowest ATMs(per 100,000 adults) in Caribbean small states?
Your answer should be compact. 10.5. What is the difference between the highest and the lowest ATMs(per 100,000 adults) of Brazil?
Ensure brevity in your answer.  12.58. What is the difference between the highest and the lowest ATMs(per 100,000 adults) of Mauritius?
Make the answer very short. 6.88. What is the difference between the highest and the lowest ATMs(per 100,000 adults) of Turkey?
Make the answer very short. 21.58. 